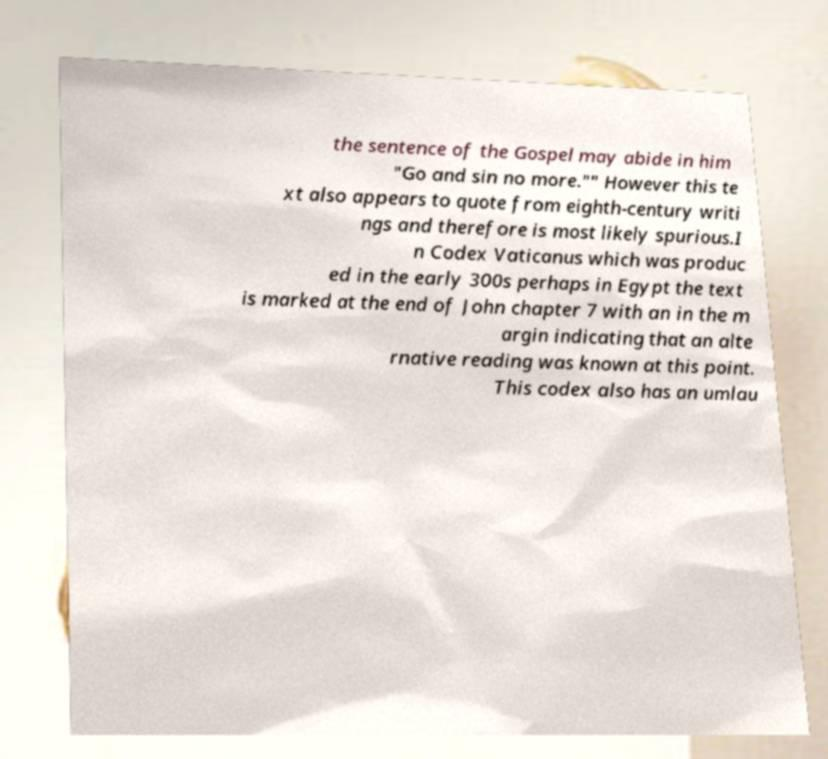Can you accurately transcribe the text from the provided image for me? the sentence of the Gospel may abide in him "Go and sin no more."" However this te xt also appears to quote from eighth-century writi ngs and therefore is most likely spurious.I n Codex Vaticanus which was produc ed in the early 300s perhaps in Egypt the text is marked at the end of John chapter 7 with an in the m argin indicating that an alte rnative reading was known at this point. This codex also has an umlau 